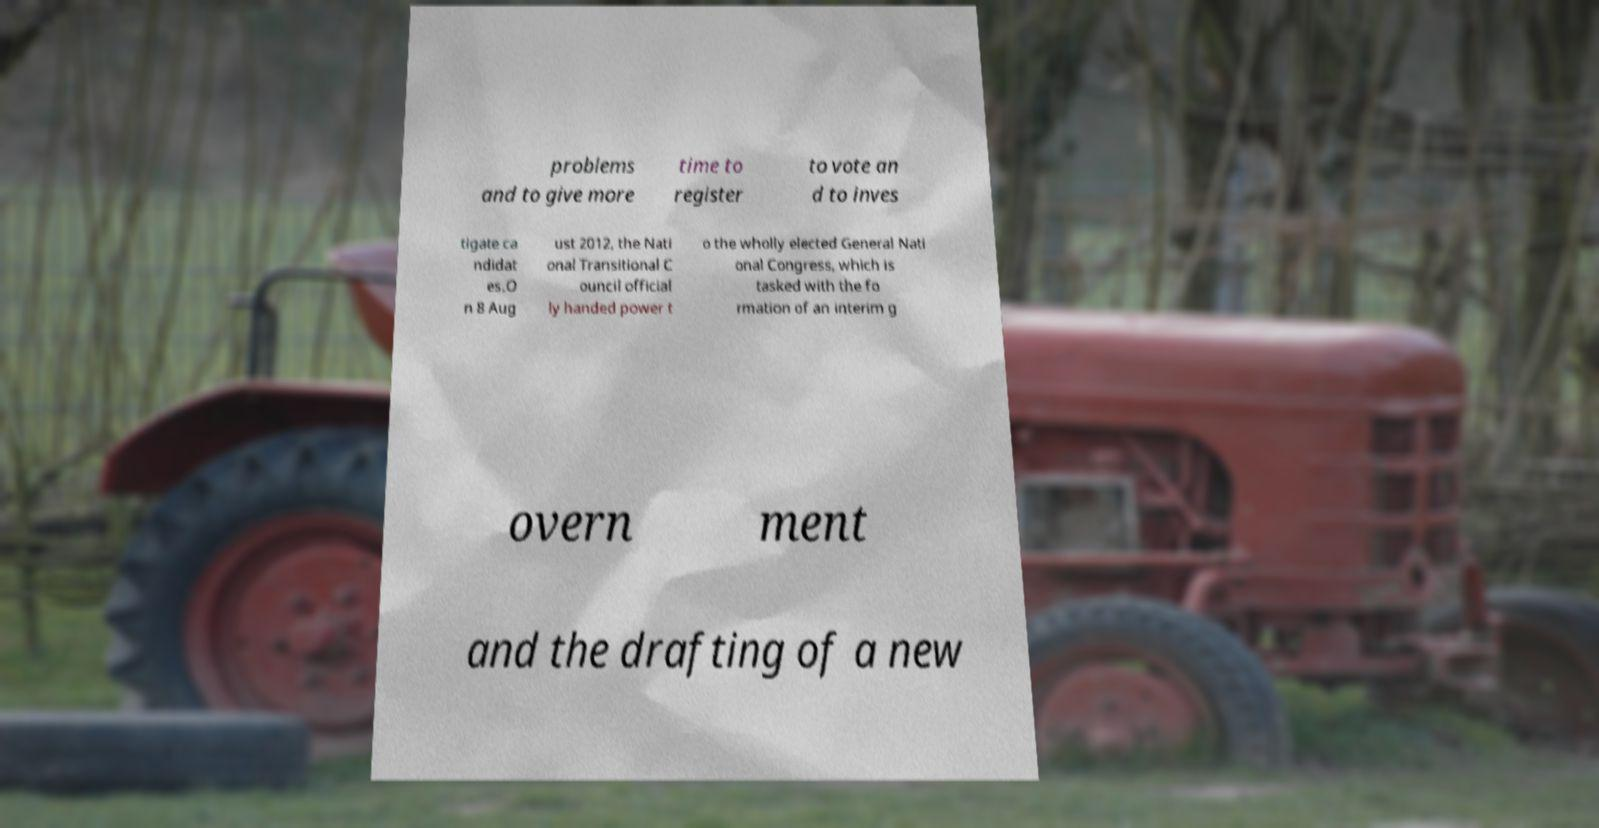Please read and relay the text visible in this image. What does it say? problems and to give more time to register to vote an d to inves tigate ca ndidat es.O n 8 Aug ust 2012, the Nati onal Transitional C ouncil official ly handed power t o the wholly elected General Nati onal Congress, which is tasked with the fo rmation of an interim g overn ment and the drafting of a new 